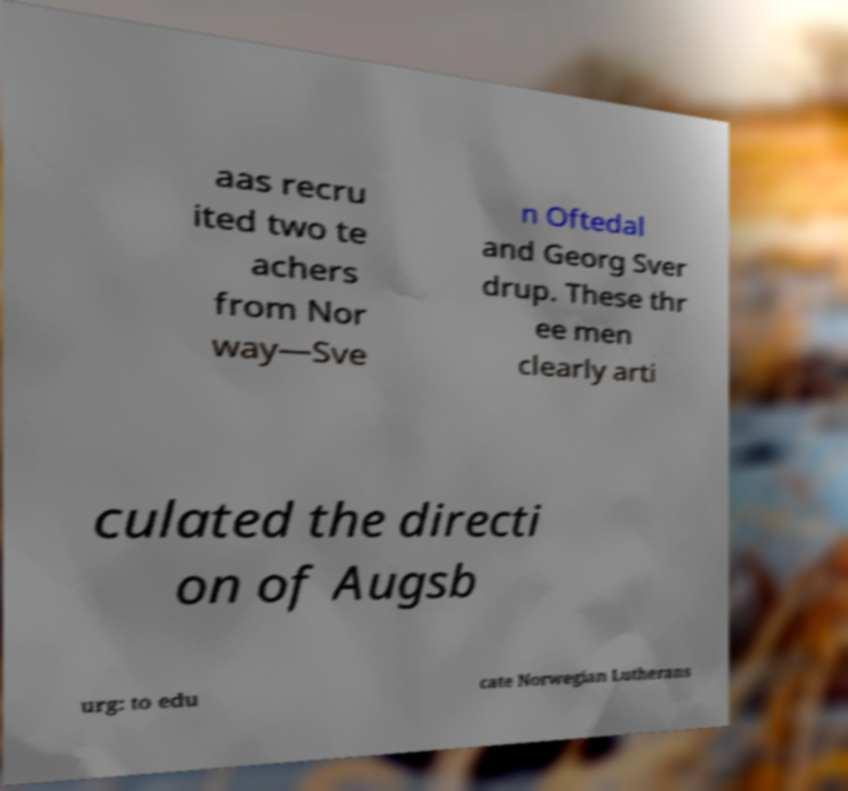Please identify and transcribe the text found in this image. aas recru ited two te achers from Nor way—Sve n Oftedal and Georg Sver drup. These thr ee men clearly arti culated the directi on of Augsb urg: to edu cate Norwegian Lutherans 